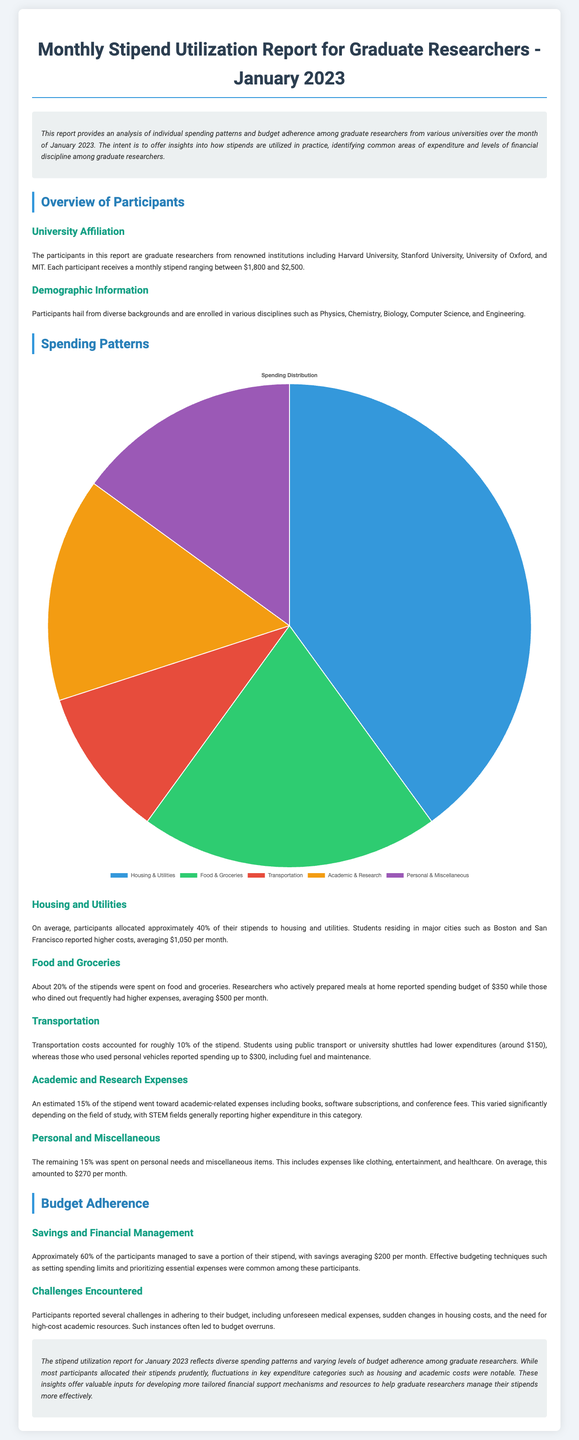What percentage of the stipend is spent on housing and utilities? The report states that on average, participants allocated approximately 40% of their stipends to housing and utilities.
Answer: 40% What is the average spending on food and groceries? The report mentions that researchers who prepared meals at home reported spending a budget of $350, while those who dined out had higher expenses averaging $500.
Answer: $350 (home) / $500 (dining out) What percentage of the stipend goes toward transportation? According to the document, transportation costs accounted for roughly 10% of the stipend.
Answer: 10% How many participants managed to save a portion of their stipend? The document states that approximately 60% of the participants managed to save a portion of their stipend.
Answer: 60% What is the average savings reported by participants? The report indicates that savings averaged $200 per month among those participants who saved a portion of their stipend.
Answer: $200 What challenges did participants face in adhering to their budget? The report lists unforeseen medical expenses, sudden changes in housing costs, and the need for high-cost academic resources as challenges.
Answer: Medical expenses, housing costs, academic resources What disciplines do the participants belong to? The document mentions that participants are enrolled in disciplines such as Physics, Chemistry, Biology, Computer Science, and Engineering.
Answer: Physics, Chemistry, Biology, Computer Science, Engineering What universities are represented in the participant group? The report states that participants come from Harvard University, Stanford University, University of Oxford, and MIT.
Answer: Harvard, Stanford, Oxford, MIT 